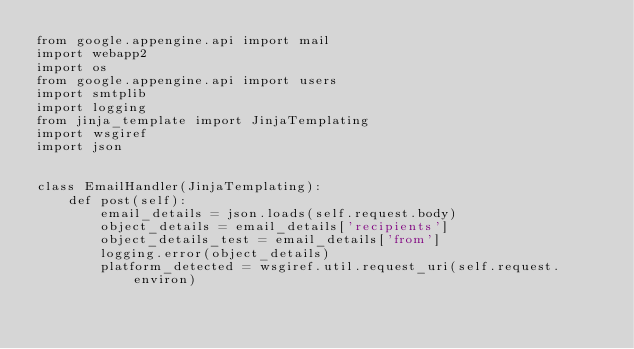<code> <loc_0><loc_0><loc_500><loc_500><_Python_>from google.appengine.api import mail
import webapp2
import os
from google.appengine.api import users
import smtplib
import logging
from jinja_template import JinjaTemplating
import wsgiref
import json


class EmailHandler(JinjaTemplating):
	def post(self):
		email_details = json.loads(self.request.body)
		object_details = email_details['recipients']
		object_details_test = email_details['from']
		logging.error(object_details)		
		platform_detected = wsgiref.util.request_uri(self.request.environ)</code> 